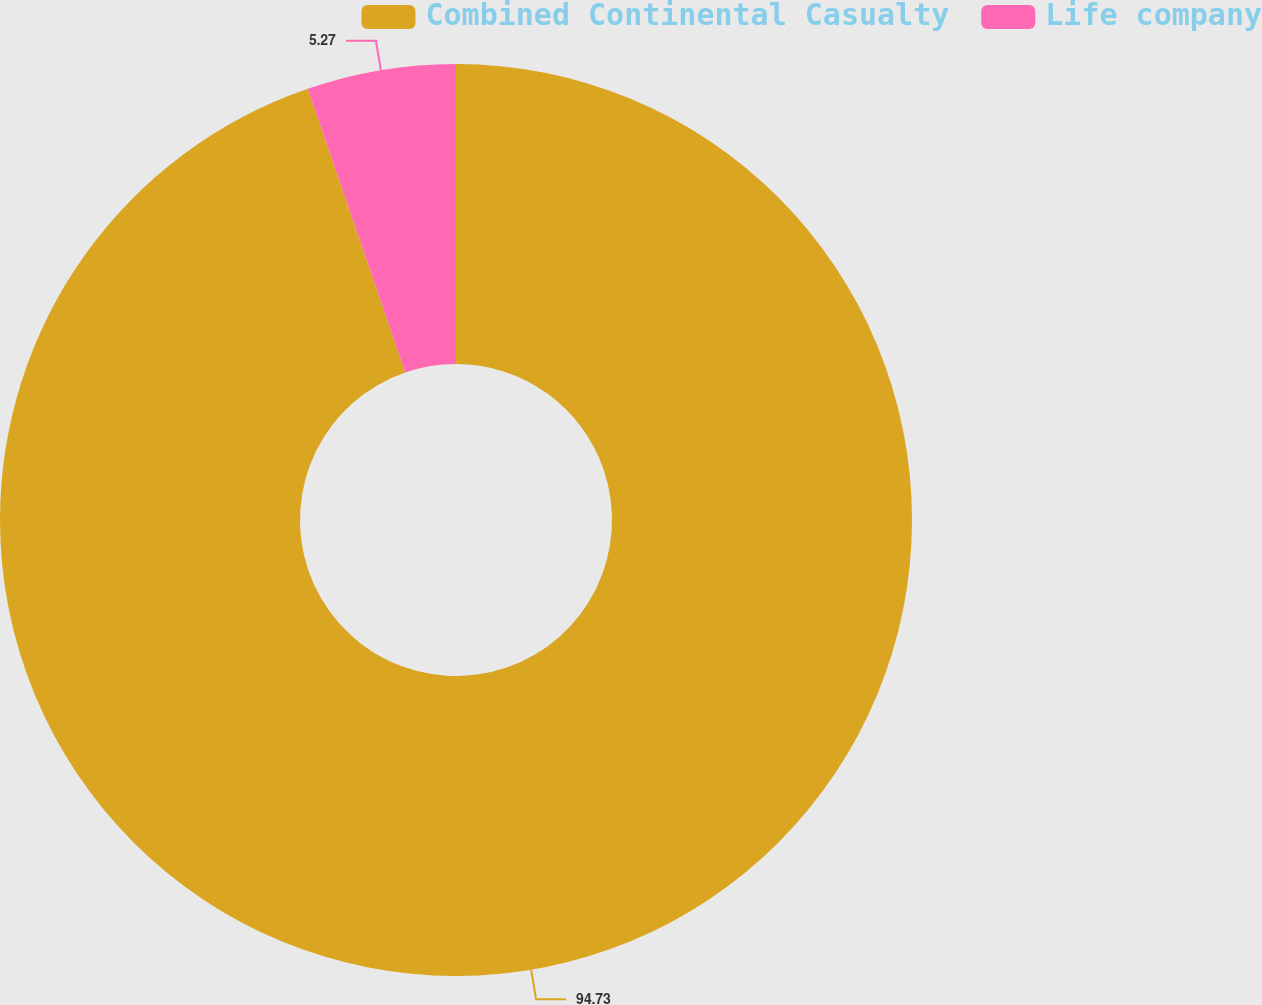Convert chart. <chart><loc_0><loc_0><loc_500><loc_500><pie_chart><fcel>Combined Continental Casualty<fcel>Life company<nl><fcel>94.73%<fcel>5.27%<nl></chart> 